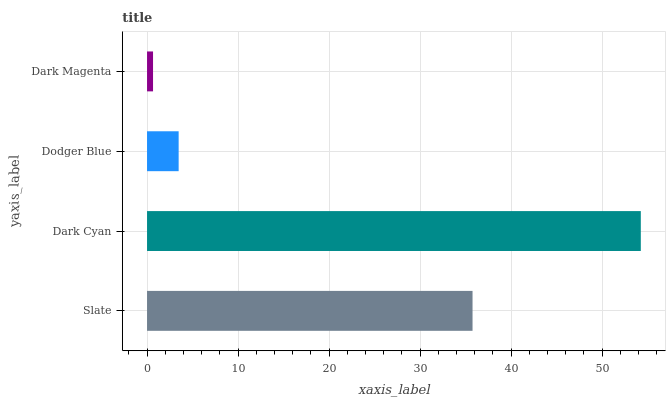Is Dark Magenta the minimum?
Answer yes or no. Yes. Is Dark Cyan the maximum?
Answer yes or no. Yes. Is Dodger Blue the minimum?
Answer yes or no. No. Is Dodger Blue the maximum?
Answer yes or no. No. Is Dark Cyan greater than Dodger Blue?
Answer yes or no. Yes. Is Dodger Blue less than Dark Cyan?
Answer yes or no. Yes. Is Dodger Blue greater than Dark Cyan?
Answer yes or no. No. Is Dark Cyan less than Dodger Blue?
Answer yes or no. No. Is Slate the high median?
Answer yes or no. Yes. Is Dodger Blue the low median?
Answer yes or no. Yes. Is Dodger Blue the high median?
Answer yes or no. No. Is Dark Cyan the low median?
Answer yes or no. No. 